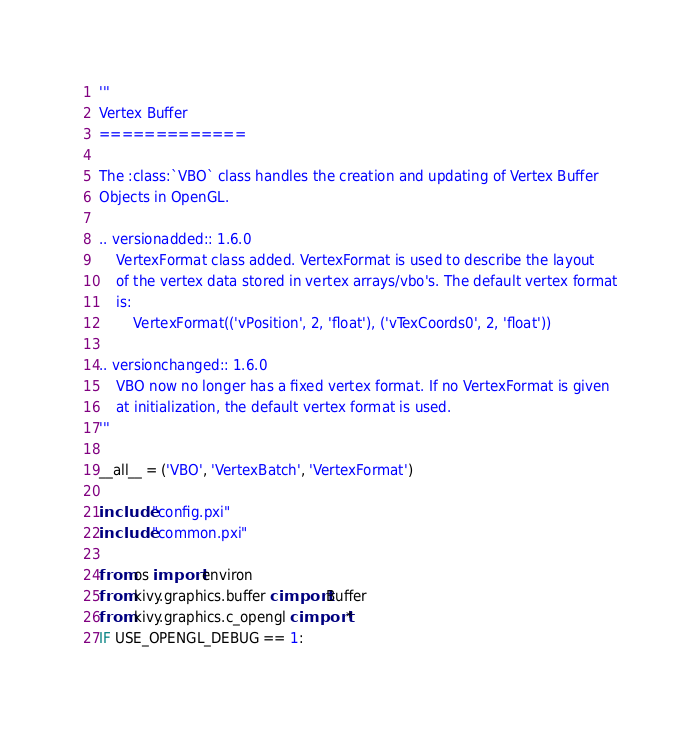Convert code to text. <code><loc_0><loc_0><loc_500><loc_500><_Cython_>'''
Vertex Buffer
=============

The :class:`VBO` class handles the creation and updating of Vertex Buffer
Objects in OpenGL.

.. versionadded:: 1.6.0
    VertexFormat class added. VertexFormat is used to describe the layout
    of the vertex data stored in vertex arrays/vbo's. The default vertex format
    is:
        VertexFormat(('vPosition', 2, 'float'), ('vTexCoords0', 2, 'float'))

.. versionchanged:: 1.6.0
    VBO now no longer has a fixed vertex format. If no VertexFormat is given
    at initialization, the default vertex format is used.
'''

__all__ = ('VBO', 'VertexBatch', 'VertexFormat')

include "config.pxi"
include "common.pxi"

from os import environ
from kivy.graphics.buffer cimport Buffer
from kivy.graphics.c_opengl cimport *
IF USE_OPENGL_DEBUG == 1:</code> 